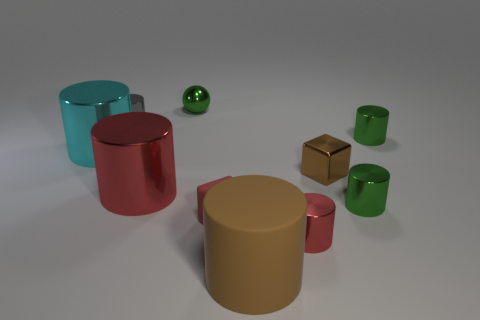How many matte things are either small gray things or tiny brown cubes?
Provide a short and direct response. 0. What is the shape of the tiny gray metallic object?
Your answer should be compact. Cylinder. Does the small brown object have the same material as the gray cylinder?
Your answer should be very brief. Yes. Are there any things that are in front of the small metallic cylinder that is on the left side of the red thing that is left of the tiny metal ball?
Offer a very short reply. Yes. How many other objects are the same shape as the cyan metallic object?
Provide a succinct answer. 6. The red thing that is both right of the green sphere and on the left side of the small red cylinder has what shape?
Provide a succinct answer. Cube. There is a big cylinder in front of the small metallic cylinder that is in front of the red matte thing that is behind the brown cylinder; what color is it?
Provide a succinct answer. Brown. Are there more big brown rubber cylinders that are right of the matte cylinder than brown cubes that are behind the green metal sphere?
Provide a short and direct response. No. How many other things are the same size as the red cube?
Keep it short and to the point. 6. There is a rubber cylinder that is the same color as the metal cube; what is its size?
Offer a terse response. Large. 